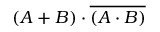Convert formula to latex. <formula><loc_0><loc_0><loc_500><loc_500>( A + B ) \cdot { \overline { ( A \cdot B ) } }</formula> 